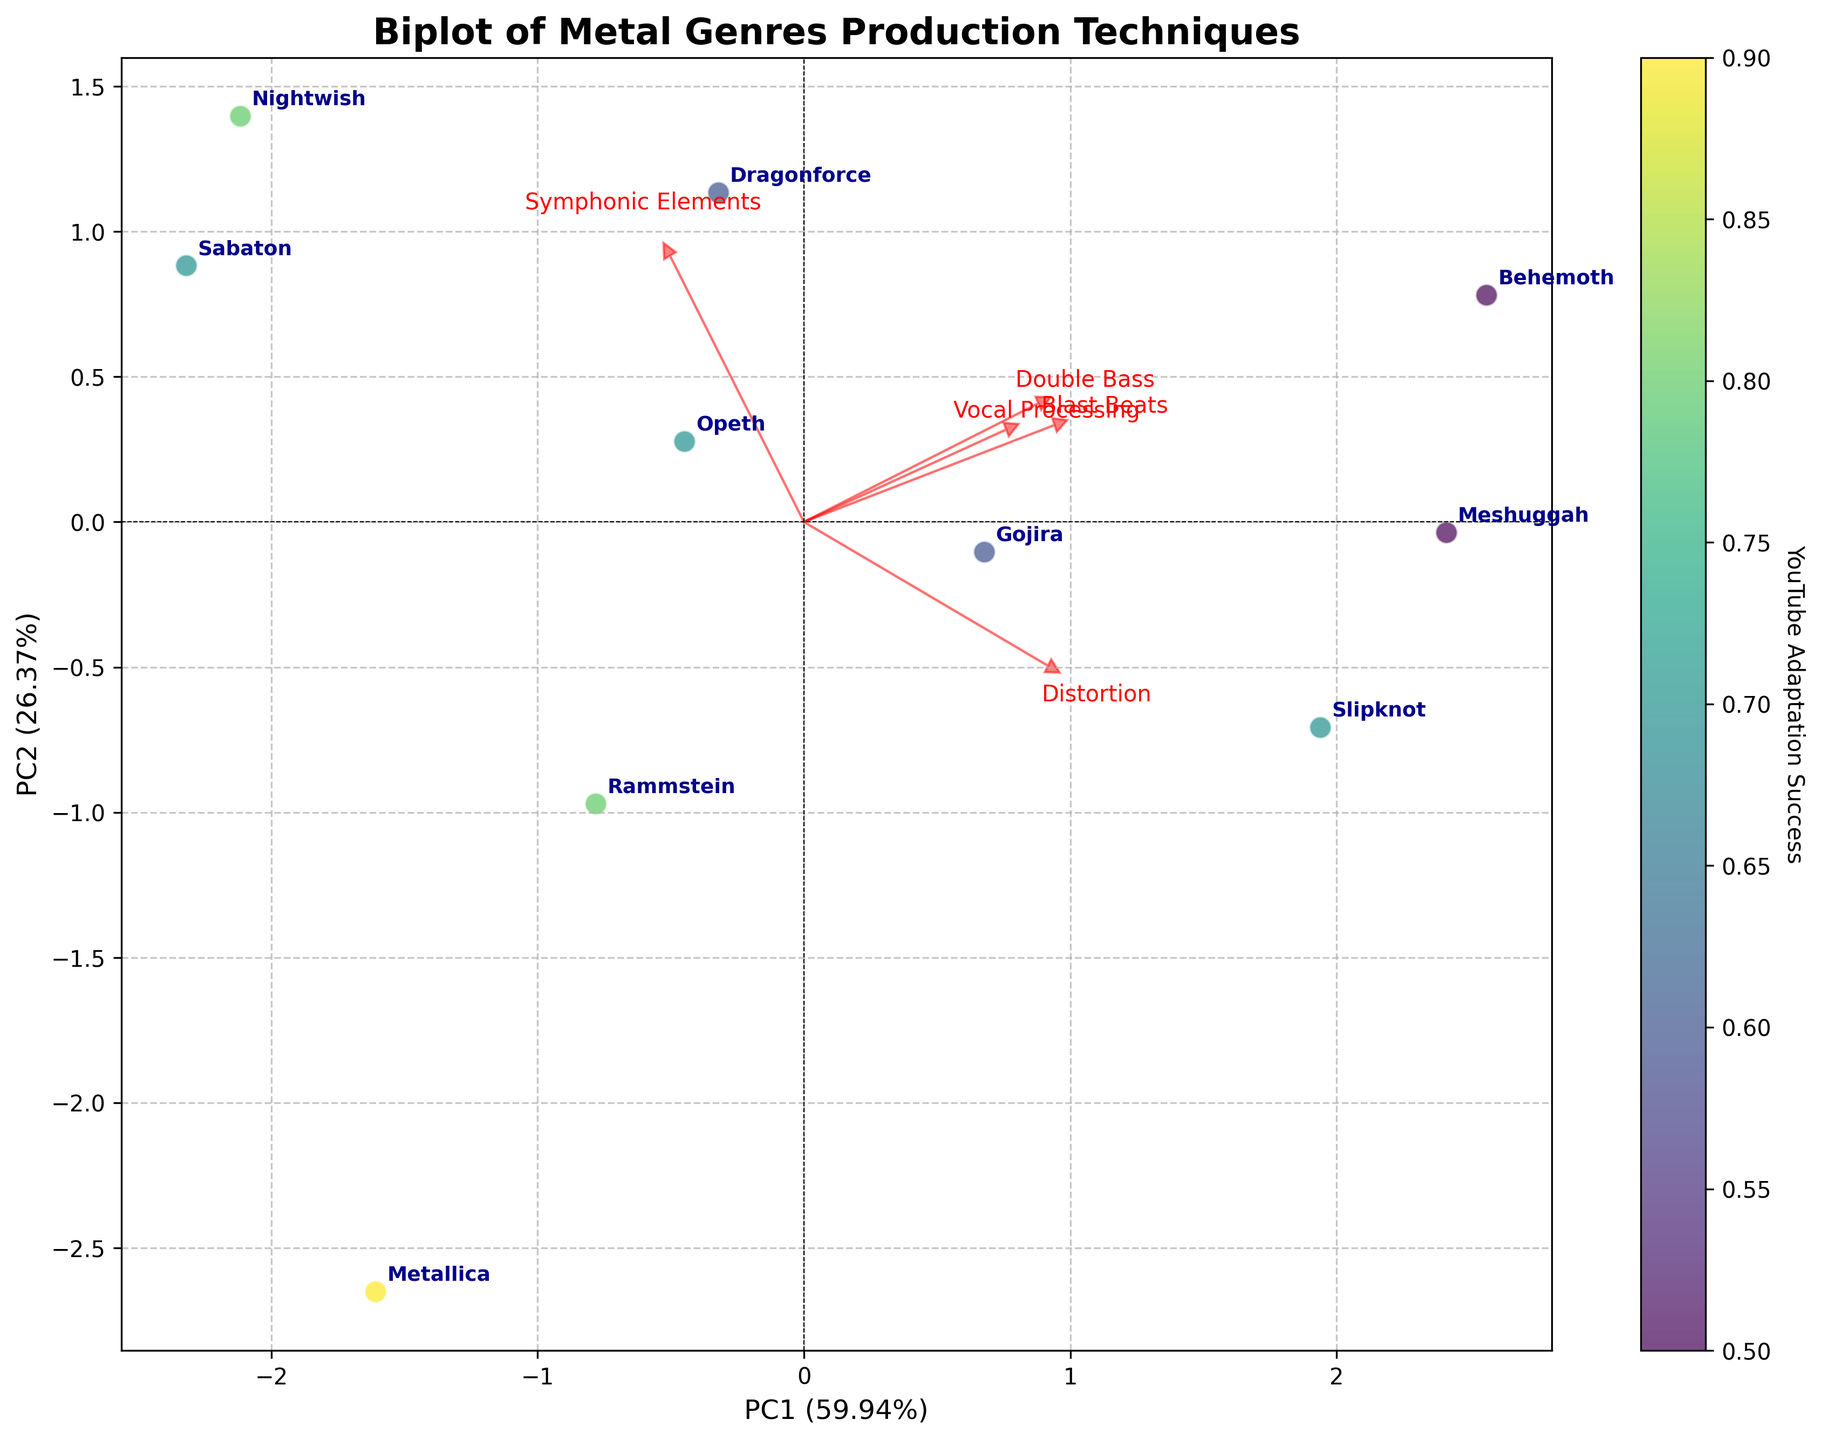What's the title of the plot? The title of the plot is usually located at the top of the figure. In this case, it is stated in the code under the `ax.set_title` function.
Answer: Biplot of Metal Genres Production Techniques Which metal band has the highest YouTube Adaptation Success? The YouTube Adaptation Success is indicated by the color intensity of the data points. The band with the highest success is represented by the point with the most intense color (y values closest to 1). According to the data, Metallica has the highest score of 0.9.
Answer: Metallica What are the labels of the x-axis and y-axis? Axis labels are typically near the axes. In the code, they are defined under `ax.set_xlabel` and `ax.set_ylabel`.
Answer: PC1 and PC2 Which feature has the longest loading arrow in the biplot? The feature with the longest arrow represents the highest loading value, indicating its importance in the principal components. By examining the lengths of arrows in the plot, we can identify Distortion as the feature with the highest loading.
Answer: Distortion How does Double Bass compare between Slipknot and Dragonforce? To compare, we need to look at the positions of Slipknot and Dragonforce relative to the Double Bass arrow. According to the data, Slipknot has a Double Bass score of 0.7, and Dragonforce has a score of 0.8.
Answer: Dragonforce has a higher Double Bass usage Which direction corresponds to the most significant positive correlation for Symphonic Elements? The loading vector for Symphonic Elements points in a specific direction. The most significant positive correlation is indicated by the direction of the arrow associated with Symphonic Elements.
Answer: Toward the top-right Which bands appear closest to each other on the plot? Bands closest to each other on the plot have similar production techniques. By visually inspecting the plot, we can see which band points are nearest to each other. Rammstein and Nightwish appear close to each other on the plot.
Answer: Rammstein and Nightwish How are Vocal Processing and Symphonic Elements related to PC1 and PC2? We interpret the biplot by checking the direction of the arrows for Vocal Processing and Symphonic Elements relative to PC1 and PC2. Both Vocal Processing and Symphonic Elements have positive values for PC1 and PC2, suggesting a positive relationship with both components.
Answer: Positively related to both PC1 and PC2 Is there a feature that is negatively correlated with PC2? We determine this by looking at the direction of the loading vectors. A negative correlation with PC2 would mean the arrow points downward. None of the loading vectors point downward significantly; thus, there is no strong negative correlation with PC2.
Answer: No What fraction of the data's variance is explained by the first principal component (PC1)? The explained variance for PC1 is displayed in the x-axis label as a percentage. Based on the code, `pca.explained_variance_ratio_[0]` tells us the fraction. The x-axis label shows PC1 (53.45%), indicating the variance it explains.
Answer: 53.45% 